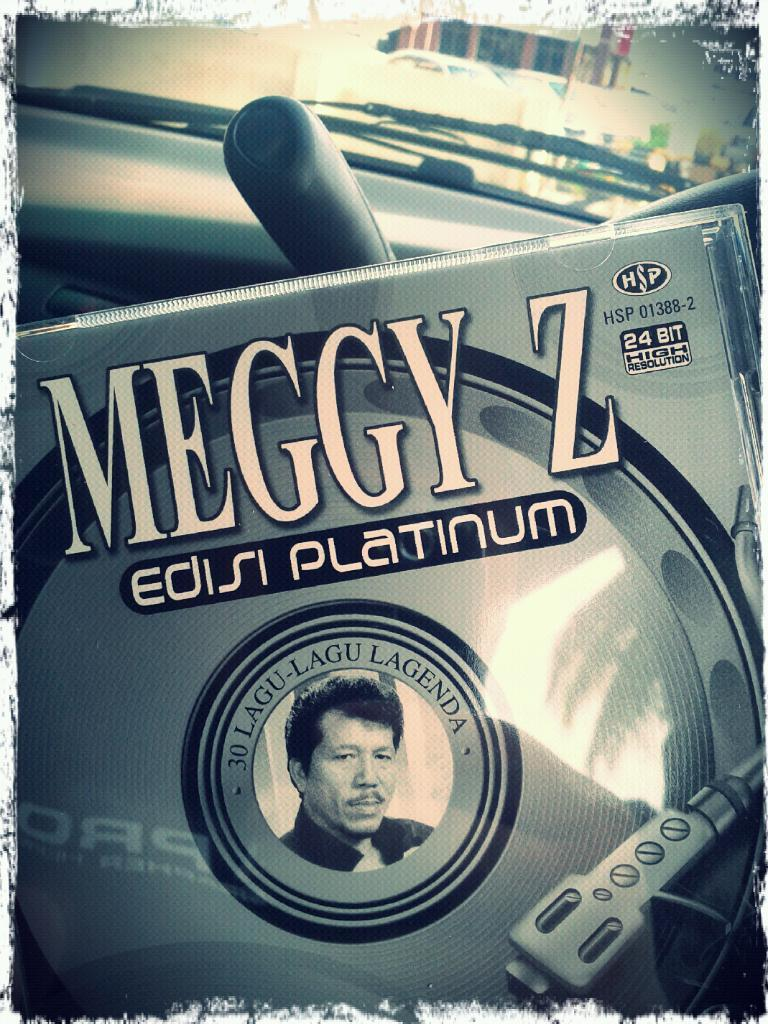What can be observed about the image's appearance? The image appears to be edited. What object is present in the image that is related to music or data storage? There is a CD case in the image. What can be seen on the CD case? The CD case has letters on it and a picture. What is the purpose of the glass in the image? The purpose of the glass is not clear from the facts provided, but it is present in the image. What is the glass wiper used for? The glass wiper is used for cleaning the glass. What type of crayon is being used to draw on the CD case in the image? There is no crayon present in the image, and the CD case does not appear to have any drawings on it. How many trains can be seen in the image? There are no trains present in the image. 